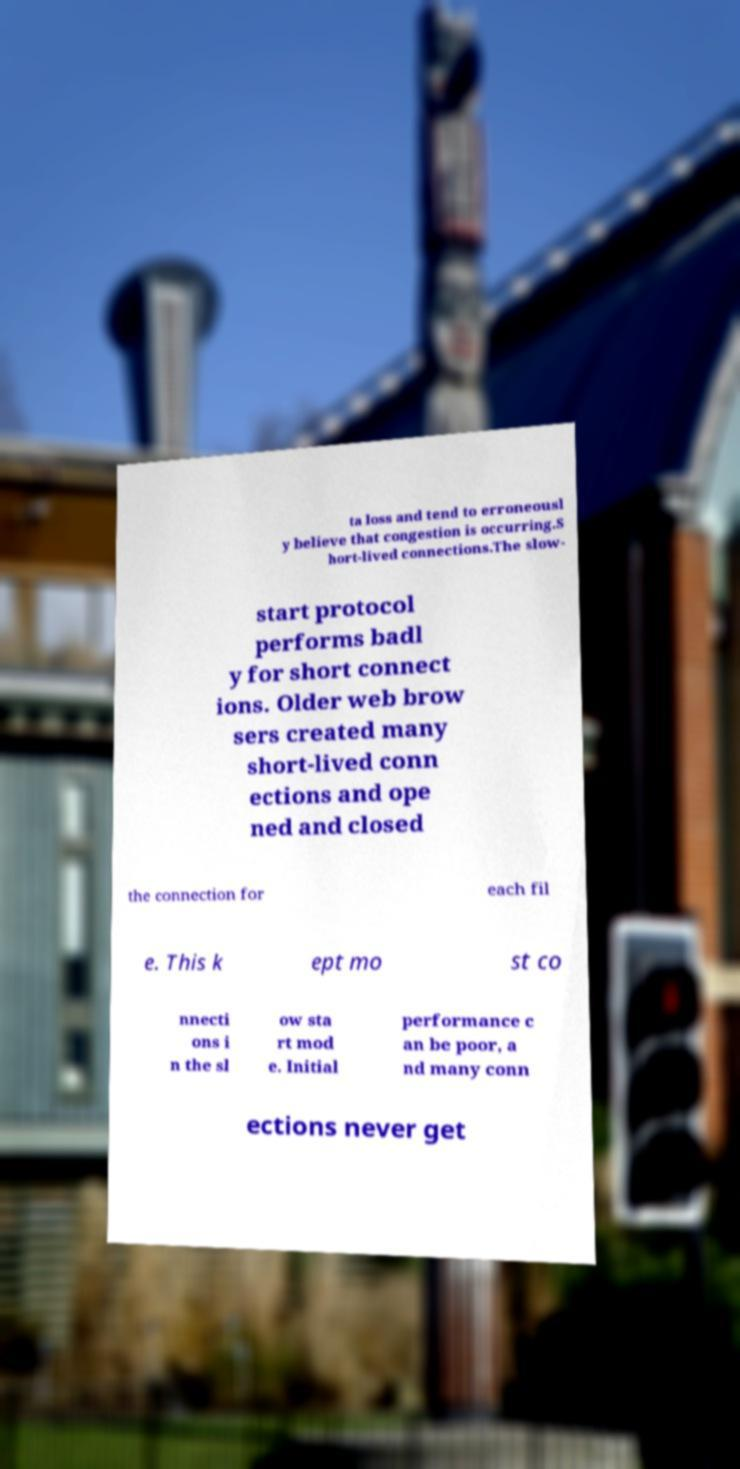Could you assist in decoding the text presented in this image and type it out clearly? ta loss and tend to erroneousl y believe that congestion is occurring.S hort-lived connections.The slow- start protocol performs badl y for short connect ions. Older web brow sers created many short-lived conn ections and ope ned and closed the connection for each fil e. This k ept mo st co nnecti ons i n the sl ow sta rt mod e. Initial performance c an be poor, a nd many conn ections never get 